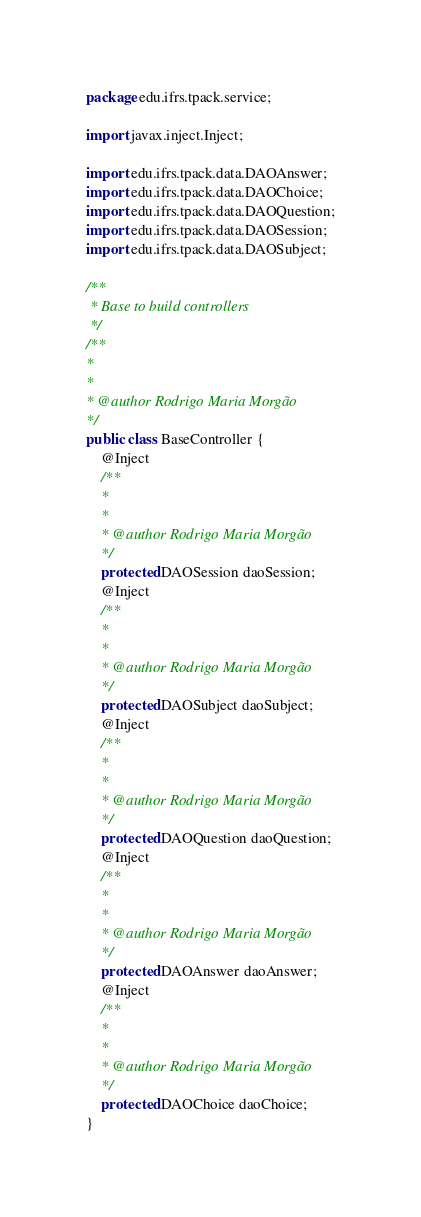<code> <loc_0><loc_0><loc_500><loc_500><_Java_>package edu.ifrs.tpack.service;

import javax.inject.Inject;

import edu.ifrs.tpack.data.DAOAnswer;
import edu.ifrs.tpack.data.DAOChoice;
import edu.ifrs.tpack.data.DAOQuestion;
import edu.ifrs.tpack.data.DAOSession;
import edu.ifrs.tpack.data.DAOSubject;

/**
 * Base to build controllers
 */
/**
* 
*
* @author Rodrigo Maria Morgão
*/
public class BaseController {
    @Inject
    /**
    * 
    *
    * @author Rodrigo Maria Morgão
    */
    protected DAOSession daoSession;
    @Inject
    /**
    * 
    *
    * @author Rodrigo Maria Morgão
    */
    protected DAOSubject daoSubject;
    @Inject
    /**
    * 
    *
    * @author Rodrigo Maria Morgão
    */
    protected DAOQuestion daoQuestion;
    @Inject
    /**
    * 
    *
    * @author Rodrigo Maria Morgão
    */
    protected DAOAnswer daoAnswer;
    @Inject
    /**
    * 
    *
    * @author Rodrigo Maria Morgão
    */
    protected DAOChoice daoChoice;
}
</code> 